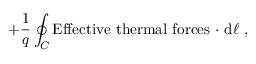<formula> <loc_0><loc_0><loc_500><loc_500>+ { \frac { 1 } { q } } \oint _ { C } E f f e c t i v e \ t h e r m a l \ f o r c e s \ \cdot \ d { \ell } \ ,</formula> 